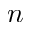<formula> <loc_0><loc_0><loc_500><loc_500>n</formula> 